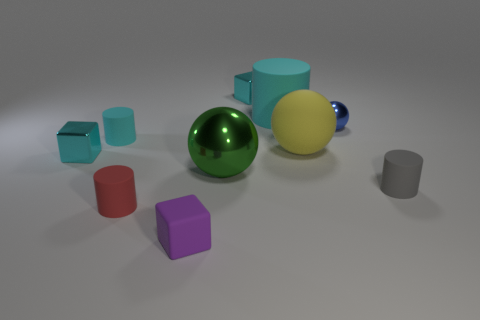There is a small object that is the same shape as the big yellow matte object; what color is it?
Give a very brief answer. Blue. Are the tiny cube that is to the right of the green metallic ball and the cyan cylinder to the left of the small matte block made of the same material?
Make the answer very short. No. Are there more large yellow matte things than big brown cylinders?
Offer a terse response. Yes. Is there anything else that is the same color as the small sphere?
Your answer should be very brief. No. Does the tiny purple object have the same material as the large green thing?
Make the answer very short. No. Are there fewer big gray spheres than purple matte blocks?
Offer a very short reply. Yes. Do the green metallic object and the blue object have the same shape?
Offer a terse response. Yes. What color is the large rubber ball?
Your answer should be compact. Yellow. What number of other things are there of the same material as the small sphere
Your answer should be compact. 3. What number of red objects are either rubber cubes or large rubber cylinders?
Make the answer very short. 0. 